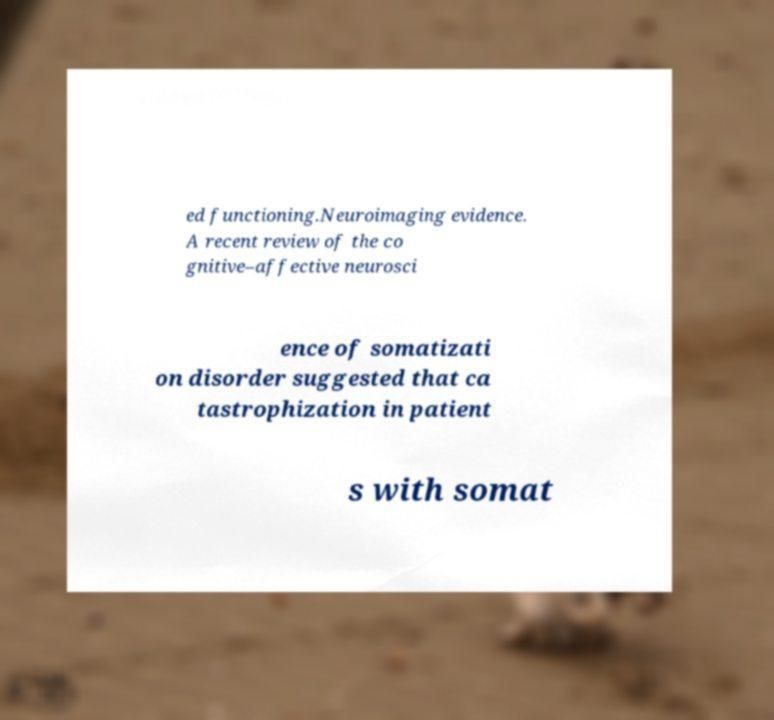Please read and relay the text visible in this image. What does it say? ed functioning.Neuroimaging evidence. A recent review of the co gnitive–affective neurosci ence of somatizati on disorder suggested that ca tastrophization in patient s with somat 